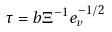<formula> <loc_0><loc_0><loc_500><loc_500>\tau & = b \Xi ^ { - 1 } e _ { v } ^ { - 1 / 2 }</formula> 